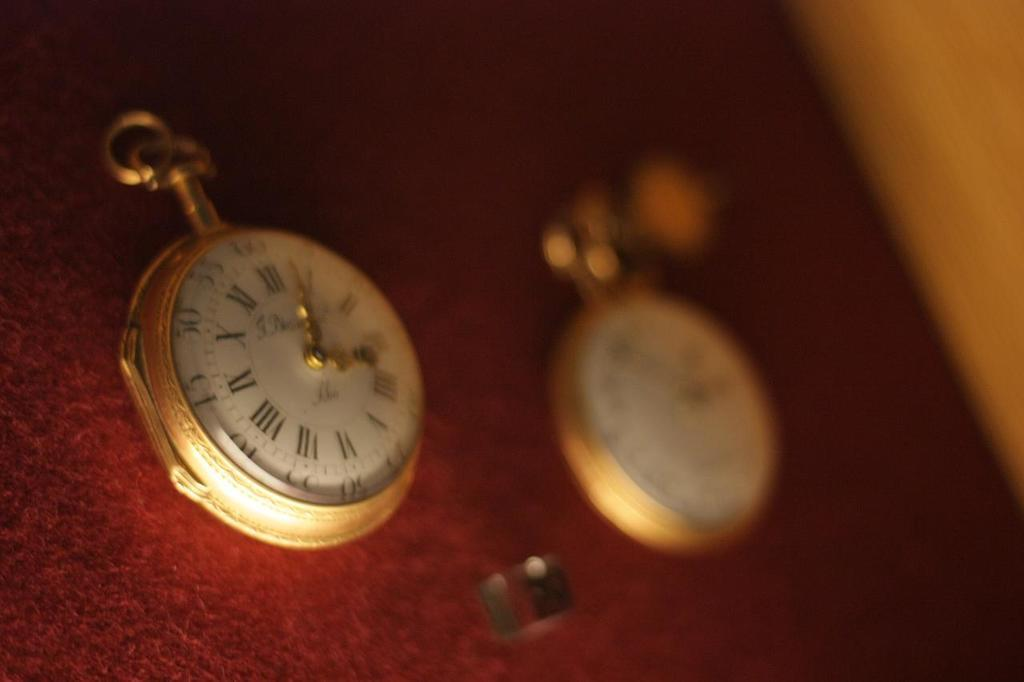<image>
Share a concise interpretation of the image provided. Two clocks reading from one to twelve on a red cover 